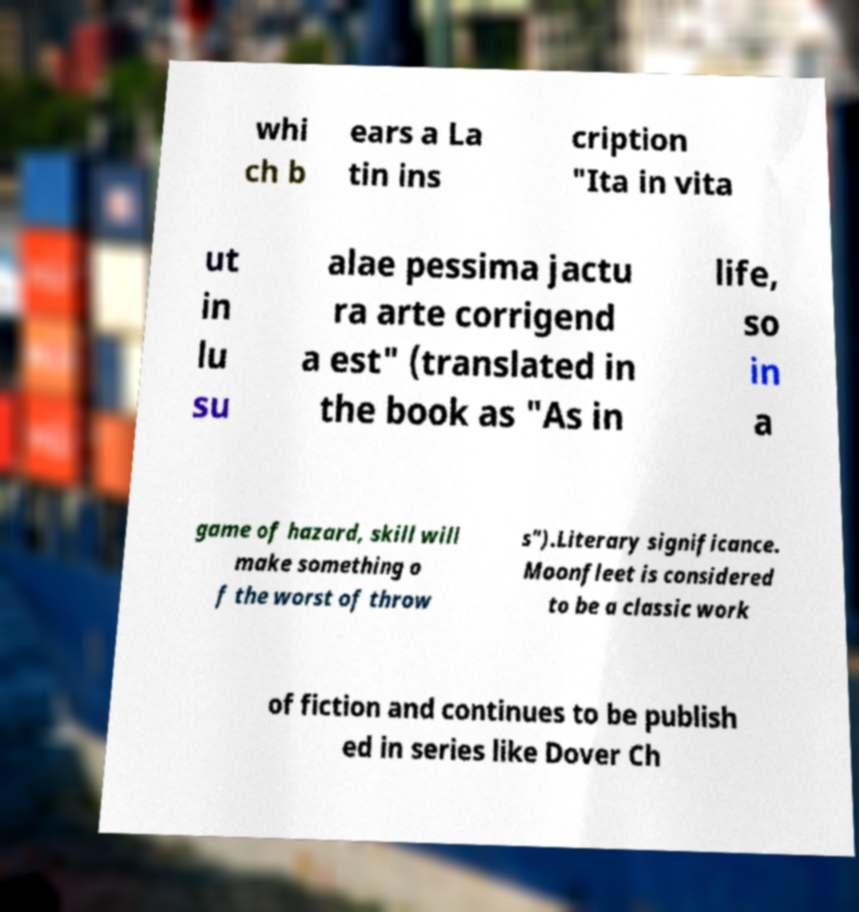Could you extract and type out the text from this image? whi ch b ears a La tin ins cription "Ita in vita ut in lu su alae pessima jactu ra arte corrigend a est" (translated in the book as "As in life, so in a game of hazard, skill will make something o f the worst of throw s").Literary significance. Moonfleet is considered to be a classic work of fiction and continues to be publish ed in series like Dover Ch 